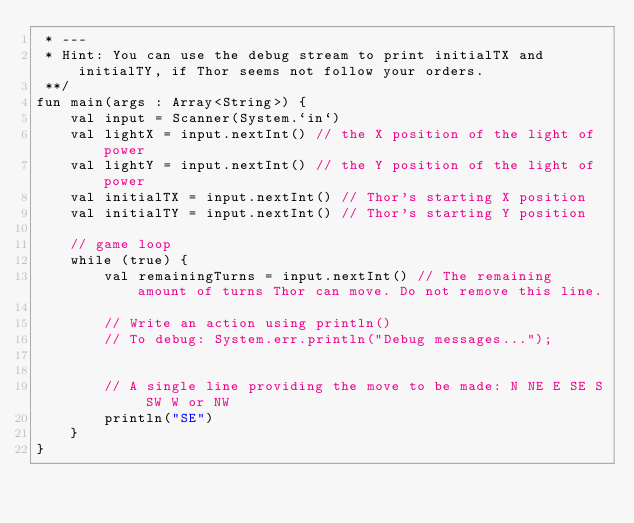<code> <loc_0><loc_0><loc_500><loc_500><_Kotlin_> * ---
 * Hint: You can use the debug stream to print initialTX and initialTY, if Thor seems not follow your orders.
 **/
fun main(args : Array<String>) {
    val input = Scanner(System.`in`)
    val lightX = input.nextInt() // the X position of the light of power
    val lightY = input.nextInt() // the Y position of the light of power
    val initialTX = input.nextInt() // Thor's starting X position
    val initialTY = input.nextInt() // Thor's starting Y position

    // game loop
    while (true) {
        val remainingTurns = input.nextInt() // The remaining amount of turns Thor can move. Do not remove this line.

        // Write an action using println()
        // To debug: System.err.println("Debug messages...");


        // A single line providing the move to be made: N NE E SE S SW W or NW
        println("SE")
    }
}</code> 